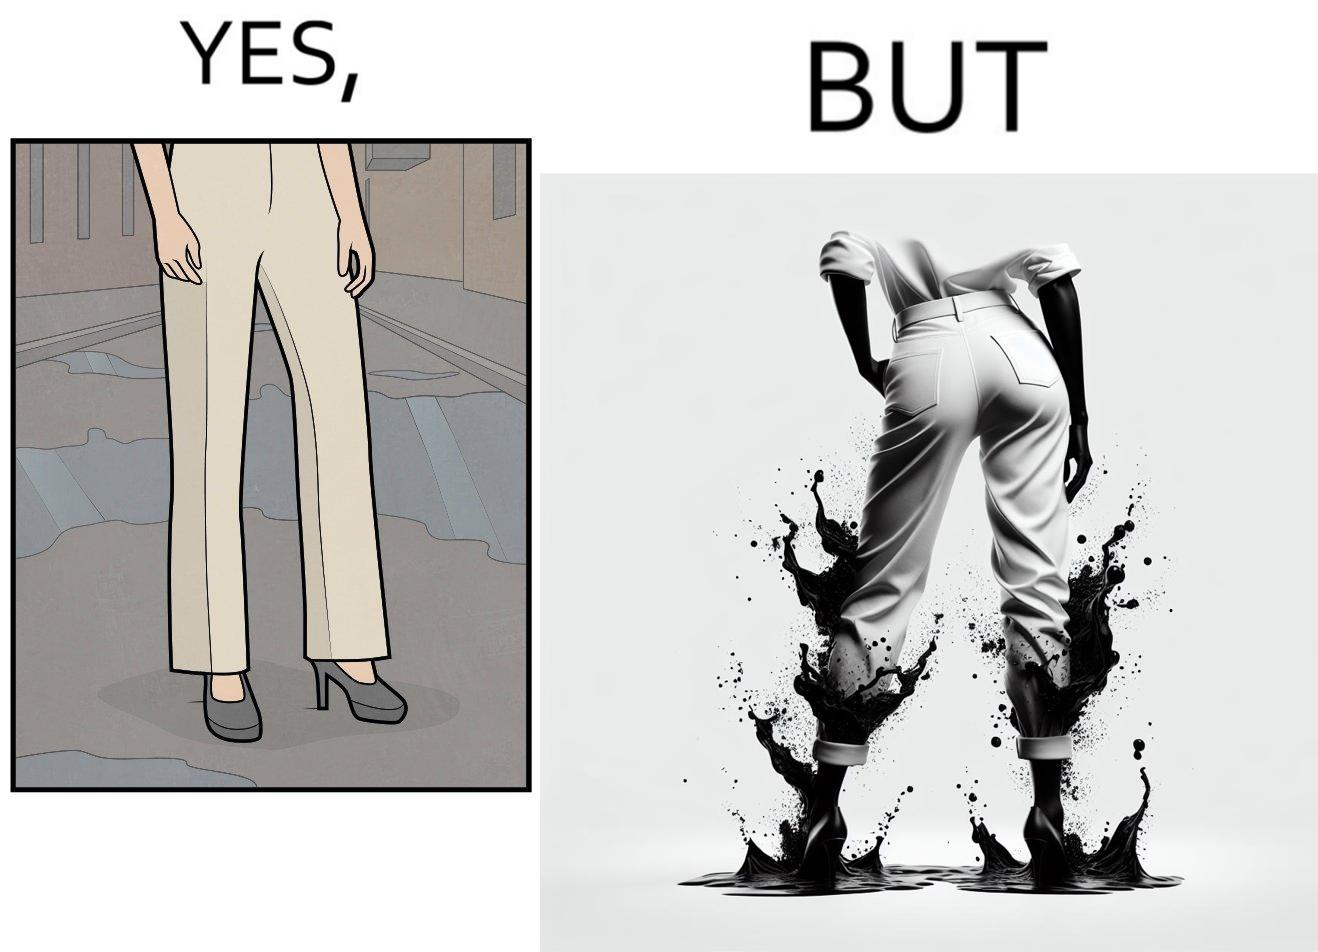What does this image depict? The image is funny, as when looking from the front, girl's pants are spick and span, while looking from the back, her pants are soaked in water, probably due to walking on a road filled with water in high heels. This is ironical, as the very reason for wearing heels (i.e. looking beautiful) is defeated, due to the heels themselves. 